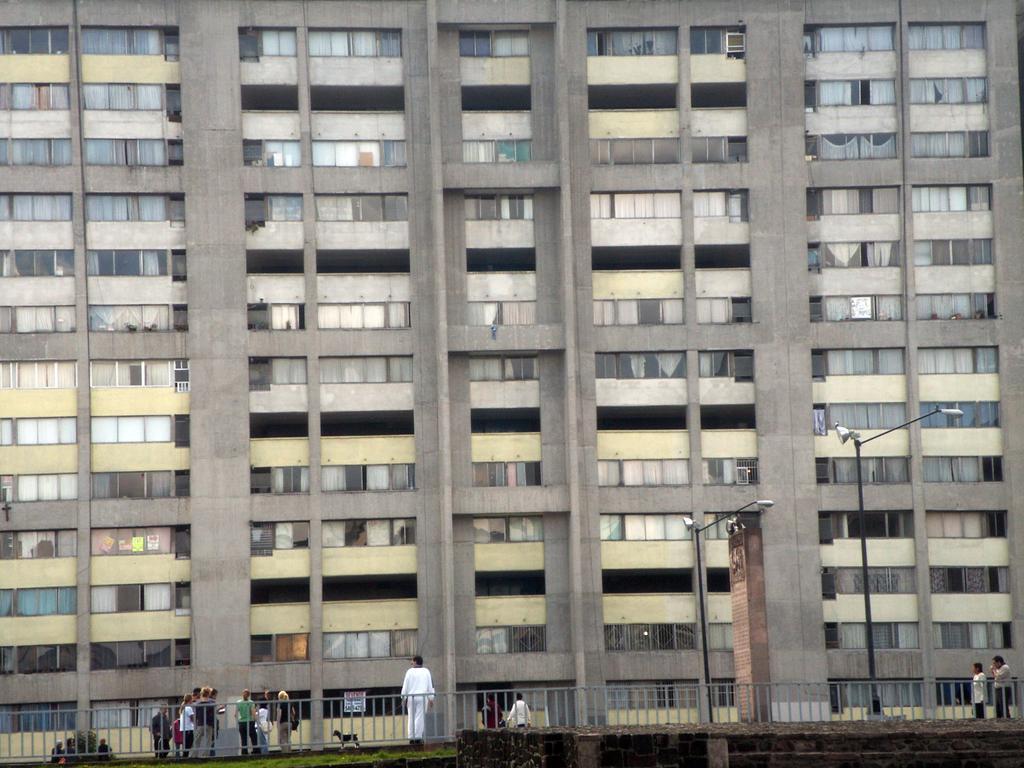How would you summarize this image in a sentence or two? In this image there is a big building to that building there are windows, in front of the building there is a road, on that road people standing and there is a fencing and poles. 